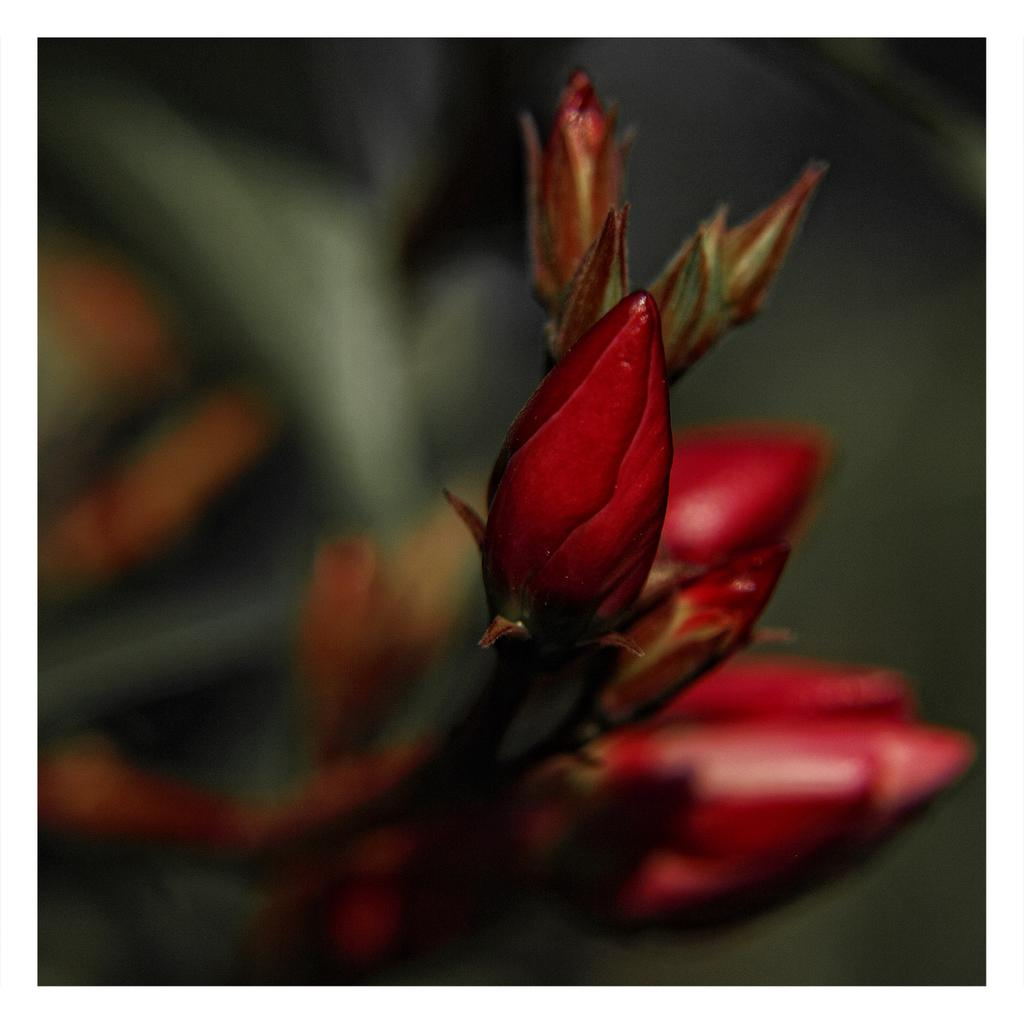What is present in the image? There are buds in the image. What color are the buds? The buds are in red color. Can you describe the background of the image? The background of the image is blurred. What type of boat can be seen in the image? There is no boat present in the image; it features red buds with a blurred background. 